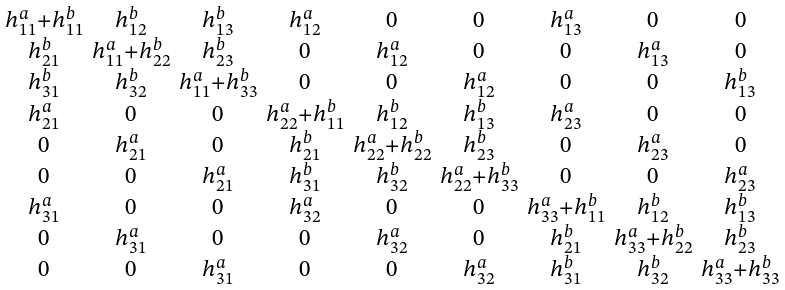Convert formula to latex. <formula><loc_0><loc_0><loc_500><loc_500>\begin{smallmatrix} h ^ { a } _ { 1 1 } + h ^ { b } _ { 1 1 } & h ^ { b } _ { 1 2 } & h ^ { b } _ { 1 3 } & h ^ { a } _ { 1 2 } & 0 & 0 & h ^ { a } _ { 1 3 } & 0 & 0 \\ h ^ { b } _ { 2 1 } & h ^ { a } _ { 1 1 } + h ^ { b } _ { 2 2 } & h ^ { b } _ { 2 3 } & 0 & h ^ { a } _ { 1 2 } & 0 & 0 & h ^ { a } _ { 1 3 } & 0 \\ h ^ { b } _ { 3 1 } & h ^ { b } _ { 3 2 } & h ^ { a } _ { 1 1 } + h ^ { b } _ { 3 3 } & 0 & 0 & h ^ { a } _ { 1 2 } & 0 & 0 & h ^ { b } _ { 1 3 } \\ h ^ { a } _ { 2 1 } & 0 & 0 & h ^ { a } _ { 2 2 } + h ^ { b } _ { 1 1 } & h ^ { b } _ { 1 2 } & h ^ { b } _ { 1 3 } & h ^ { a } _ { 2 3 } & 0 & 0 \\ 0 & h ^ { a } _ { 2 1 } & 0 & h ^ { b } _ { 2 1 } & h ^ { a } _ { 2 2 } + h ^ { b } _ { 2 2 } & h ^ { b } _ { 2 3 } & 0 & h ^ { a } _ { 2 3 } & 0 \\ 0 & 0 & h ^ { a } _ { 2 1 } & h ^ { b } _ { 3 1 } & h ^ { b } _ { 3 2 } & h ^ { a } _ { 2 2 } + h ^ { b } _ { 3 3 } & 0 & 0 & h ^ { a } _ { 2 3 } \\ h ^ { a } _ { 3 1 } & 0 & 0 & h ^ { a } _ { 3 2 } & 0 & 0 & h ^ { a } _ { 3 3 } + h ^ { b } _ { 1 1 } & h ^ { b } _ { 1 2 } & h ^ { b } _ { 1 3 } \\ 0 & h ^ { a } _ { 3 1 } & 0 & 0 & h ^ { a } _ { 3 2 } & 0 & h ^ { b } _ { 2 1 } & h ^ { a } _ { 3 3 } + h ^ { b } _ { 2 2 } & h ^ { b } _ { 2 3 } \\ 0 & 0 & h ^ { a } _ { 3 1 } & 0 & 0 & h ^ { a } _ { 3 2 } & h ^ { b } _ { 3 1 } & h ^ { b } _ { 3 2 } & h ^ { a } _ { 3 3 } + h ^ { b } _ { 3 3 } \end{smallmatrix}</formula> 